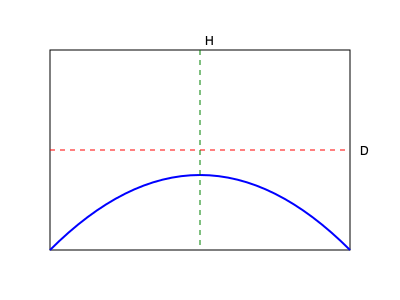A new drainage system is being proposed for a flood-prone area. The cross-section of the pipe is shown above, where D represents the diameter and H the maximum depth. If D = 3 meters and the cross-sectional area is approximately 5.3 square meters, estimate the maximum flow capacity of the pipe in cubic meters per second, assuming a flow velocity of 2 m/s. To solve this problem, we'll follow these steps:

1) The cross-sectional shape of the pipe is a circular segment.

2) We're given that the area of this segment is approximately 5.3 m².

3) The flow capacity is calculated by multiplying the cross-sectional area by the flow velocity.

4) The flow velocity is given as 2 m/s.

5) Therefore, we can calculate the flow capacity as:

   Flow Capacity = Cross-sectional Area × Flow Velocity
                 = 5.3 m² × 2 m/s
                 = 10.6 m³/s

6) Rounding to one decimal place for practical purposes:

   Flow Capacity ≈ 10.6 m³/s

This capacity represents the maximum volume of water that can flow through the pipe per second, which is crucial information for managing potential flooding scenarios.
Answer: 10.6 m³/s 